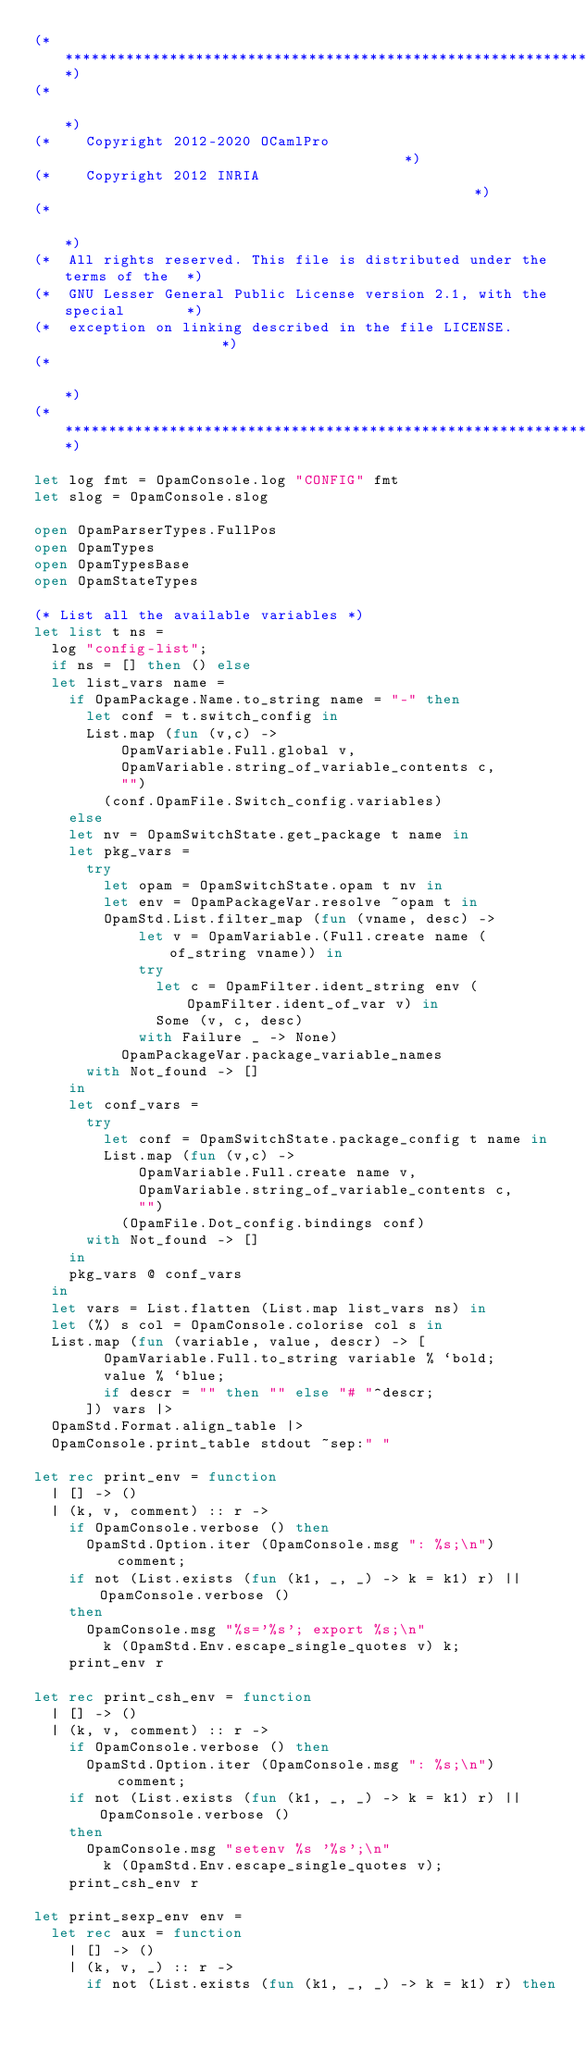Convert code to text. <code><loc_0><loc_0><loc_500><loc_500><_OCaml_>(**************************************************************************)
(*                                                                        *)
(*    Copyright 2012-2020 OCamlPro                                        *)
(*    Copyright 2012 INRIA                                                *)
(*                                                                        *)
(*  All rights reserved. This file is distributed under the terms of the  *)
(*  GNU Lesser General Public License version 2.1, with the special       *)
(*  exception on linking described in the file LICENSE.                   *)
(*                                                                        *)
(**************************************************************************)

let log fmt = OpamConsole.log "CONFIG" fmt
let slog = OpamConsole.slog

open OpamParserTypes.FullPos
open OpamTypes
open OpamTypesBase
open OpamStateTypes

(* List all the available variables *)
let list t ns =
  log "config-list";
  if ns = [] then () else
  let list_vars name =
    if OpamPackage.Name.to_string name = "-" then
      let conf = t.switch_config in
      List.map (fun (v,c) ->
          OpamVariable.Full.global v,
          OpamVariable.string_of_variable_contents c,
          "")
        (conf.OpamFile.Switch_config.variables)
    else
    let nv = OpamSwitchState.get_package t name in
    let pkg_vars =
      try
        let opam = OpamSwitchState.opam t nv in
        let env = OpamPackageVar.resolve ~opam t in
        OpamStd.List.filter_map (fun (vname, desc) ->
            let v = OpamVariable.(Full.create name (of_string vname)) in
            try
              let c = OpamFilter.ident_string env (OpamFilter.ident_of_var v) in
              Some (v, c, desc)
            with Failure _ -> None)
          OpamPackageVar.package_variable_names
      with Not_found -> []
    in
    let conf_vars =
      try
        let conf = OpamSwitchState.package_config t name in
        List.map (fun (v,c) ->
            OpamVariable.Full.create name v,
            OpamVariable.string_of_variable_contents c,
            "")
          (OpamFile.Dot_config.bindings conf)
      with Not_found -> []
    in
    pkg_vars @ conf_vars
  in
  let vars = List.flatten (List.map list_vars ns) in
  let (%) s col = OpamConsole.colorise col s in
  List.map (fun (variable, value, descr) -> [
        OpamVariable.Full.to_string variable % `bold;
        value % `blue;
        if descr = "" then "" else "# "^descr;
      ]) vars |>
  OpamStd.Format.align_table |>
  OpamConsole.print_table stdout ~sep:" "

let rec print_env = function
  | [] -> ()
  | (k, v, comment) :: r ->
    if OpamConsole.verbose () then
      OpamStd.Option.iter (OpamConsole.msg ": %s;\n") comment;
    if not (List.exists (fun (k1, _, _) -> k = k1) r) || OpamConsole.verbose ()
    then
      OpamConsole.msg "%s='%s'; export %s;\n"
        k (OpamStd.Env.escape_single_quotes v) k;
    print_env r

let rec print_csh_env = function
  | [] -> ()
  | (k, v, comment) :: r ->
    if OpamConsole.verbose () then
      OpamStd.Option.iter (OpamConsole.msg ": %s;\n") comment;
    if not (List.exists (fun (k1, _, _) -> k = k1) r) || OpamConsole.verbose ()
    then
      OpamConsole.msg "setenv %s '%s';\n"
        k (OpamStd.Env.escape_single_quotes v);
    print_csh_env r

let print_sexp_env env =
  let rec aux = function
    | [] -> ()
    | (k, v, _) :: r ->
      if not (List.exists (fun (k1, _, _) -> k = k1) r) then</code> 